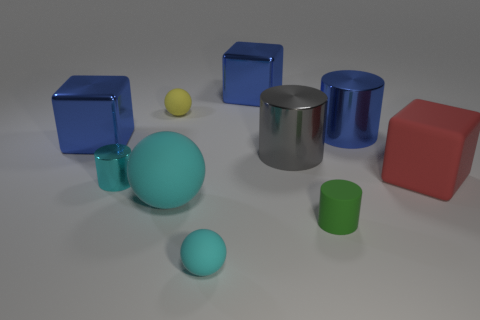Are there any large green rubber things that have the same shape as the tiny yellow thing?
Offer a terse response. No. There is a yellow matte thing that is the same size as the cyan shiny thing; what shape is it?
Your answer should be compact. Sphere. There is a tiny rubber object behind the tiny matte thing right of the metal block right of the small cyan rubber sphere; what shape is it?
Offer a very short reply. Sphere. There is a small cyan rubber thing; does it have the same shape as the big shiny thing right of the large gray object?
Offer a terse response. No. How many big objects are brown matte blocks or yellow things?
Make the answer very short. 0. Are there any red metallic spheres of the same size as the yellow thing?
Make the answer very short. No. The matte cylinder in front of the shiny cube behind the tiny matte thing behind the big blue shiny cylinder is what color?
Provide a succinct answer. Green. Is the large ball made of the same material as the small object that is in front of the green object?
Provide a short and direct response. Yes. The gray shiny object that is the same shape as the tiny cyan metal object is what size?
Make the answer very short. Large. Are there an equal number of large metal things to the right of the red matte block and big metal cylinders to the left of the big cyan matte ball?
Give a very brief answer. Yes. 